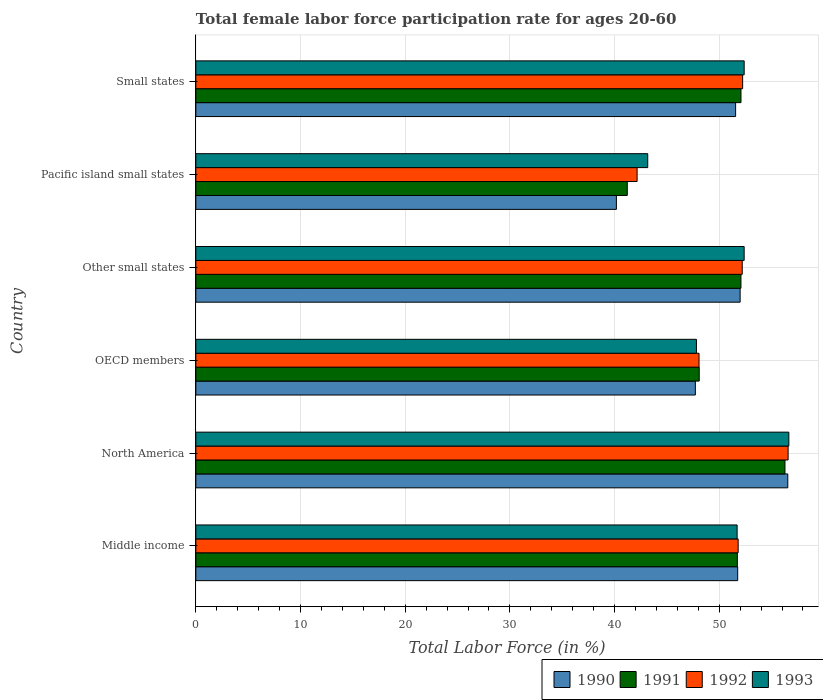How many groups of bars are there?
Offer a very short reply. 6. Are the number of bars per tick equal to the number of legend labels?
Keep it short and to the point. Yes. Are the number of bars on each tick of the Y-axis equal?
Ensure brevity in your answer.  Yes. How many bars are there on the 6th tick from the bottom?
Provide a short and direct response. 4. In how many cases, is the number of bars for a given country not equal to the number of legend labels?
Offer a very short reply. 0. What is the female labor force participation rate in 1993 in Middle income?
Give a very brief answer. 51.71. Across all countries, what is the maximum female labor force participation rate in 1991?
Keep it short and to the point. 56.28. Across all countries, what is the minimum female labor force participation rate in 1993?
Offer a terse response. 43.17. In which country was the female labor force participation rate in 1992 minimum?
Offer a terse response. Pacific island small states. What is the total female labor force participation rate in 1993 in the graph?
Offer a terse response. 304.12. What is the difference between the female labor force participation rate in 1991 in North America and that in Pacific island small states?
Offer a terse response. 15.07. What is the difference between the female labor force participation rate in 1991 in Pacific island small states and the female labor force participation rate in 1993 in Small states?
Ensure brevity in your answer.  -11.17. What is the average female labor force participation rate in 1992 per country?
Offer a terse response. 50.51. What is the difference between the female labor force participation rate in 1990 and female labor force participation rate in 1992 in Other small states?
Give a very brief answer. -0.2. What is the ratio of the female labor force participation rate in 1991 in OECD members to that in Small states?
Your response must be concise. 0.92. Is the female labor force participation rate in 1991 in OECD members less than that in Pacific island small states?
Your answer should be compact. No. What is the difference between the highest and the second highest female labor force participation rate in 1990?
Offer a very short reply. 4.55. What is the difference between the highest and the lowest female labor force participation rate in 1993?
Offer a terse response. 13.48. Is the sum of the female labor force participation rate in 1993 in Middle income and Small states greater than the maximum female labor force participation rate in 1991 across all countries?
Give a very brief answer. Yes. What does the 1st bar from the top in Small states represents?
Offer a very short reply. 1993. What does the 2nd bar from the bottom in North America represents?
Your answer should be very brief. 1991. Is it the case that in every country, the sum of the female labor force participation rate in 1990 and female labor force participation rate in 1992 is greater than the female labor force participation rate in 1993?
Offer a very short reply. Yes. How many bars are there?
Your answer should be compact. 24. Are all the bars in the graph horizontal?
Provide a succinct answer. Yes. How many countries are there in the graph?
Give a very brief answer. 6. What is the difference between two consecutive major ticks on the X-axis?
Offer a terse response. 10. Are the values on the major ticks of X-axis written in scientific E-notation?
Offer a very short reply. No. Does the graph contain grids?
Keep it short and to the point. Yes. Where does the legend appear in the graph?
Offer a terse response. Bottom right. How many legend labels are there?
Keep it short and to the point. 4. How are the legend labels stacked?
Provide a succinct answer. Horizontal. What is the title of the graph?
Your answer should be compact. Total female labor force participation rate for ages 20-60. Does "2007" appear as one of the legend labels in the graph?
Your answer should be very brief. No. What is the label or title of the X-axis?
Give a very brief answer. Total Labor Force (in %). What is the Total Labor Force (in %) in 1990 in Middle income?
Keep it short and to the point. 51.76. What is the Total Labor Force (in %) of 1991 in Middle income?
Your answer should be very brief. 51.73. What is the Total Labor Force (in %) of 1992 in Middle income?
Your answer should be compact. 51.81. What is the Total Labor Force (in %) in 1993 in Middle income?
Provide a succinct answer. 51.71. What is the Total Labor Force (in %) of 1990 in North America?
Keep it short and to the point. 56.55. What is the Total Labor Force (in %) in 1991 in North America?
Provide a succinct answer. 56.28. What is the Total Labor Force (in %) in 1992 in North America?
Your answer should be compact. 56.58. What is the Total Labor Force (in %) in 1993 in North America?
Provide a succinct answer. 56.65. What is the Total Labor Force (in %) in 1990 in OECD members?
Ensure brevity in your answer.  47.72. What is the Total Labor Force (in %) of 1991 in OECD members?
Your response must be concise. 48.09. What is the Total Labor Force (in %) in 1992 in OECD members?
Ensure brevity in your answer.  48.07. What is the Total Labor Force (in %) of 1993 in OECD members?
Make the answer very short. 47.82. What is the Total Labor Force (in %) in 1990 in Other small states?
Your answer should be very brief. 52. What is the Total Labor Force (in %) of 1991 in Other small states?
Ensure brevity in your answer.  52.08. What is the Total Labor Force (in %) in 1992 in Other small states?
Ensure brevity in your answer.  52.2. What is the Total Labor Force (in %) in 1993 in Other small states?
Offer a very short reply. 52.38. What is the Total Labor Force (in %) of 1990 in Pacific island small states?
Offer a terse response. 40.18. What is the Total Labor Force (in %) of 1991 in Pacific island small states?
Give a very brief answer. 41.21. What is the Total Labor Force (in %) in 1992 in Pacific island small states?
Make the answer very short. 42.15. What is the Total Labor Force (in %) in 1993 in Pacific island small states?
Offer a terse response. 43.17. What is the Total Labor Force (in %) of 1990 in Small states?
Offer a terse response. 51.57. What is the Total Labor Force (in %) of 1991 in Small states?
Ensure brevity in your answer.  52.08. What is the Total Labor Force (in %) of 1992 in Small states?
Your answer should be compact. 52.24. What is the Total Labor Force (in %) in 1993 in Small states?
Keep it short and to the point. 52.38. Across all countries, what is the maximum Total Labor Force (in %) of 1990?
Provide a short and direct response. 56.55. Across all countries, what is the maximum Total Labor Force (in %) in 1991?
Make the answer very short. 56.28. Across all countries, what is the maximum Total Labor Force (in %) of 1992?
Your answer should be compact. 56.58. Across all countries, what is the maximum Total Labor Force (in %) in 1993?
Offer a terse response. 56.65. Across all countries, what is the minimum Total Labor Force (in %) in 1990?
Keep it short and to the point. 40.18. Across all countries, what is the minimum Total Labor Force (in %) in 1991?
Your answer should be very brief. 41.21. Across all countries, what is the minimum Total Labor Force (in %) in 1992?
Make the answer very short. 42.15. Across all countries, what is the minimum Total Labor Force (in %) of 1993?
Give a very brief answer. 43.17. What is the total Total Labor Force (in %) in 1990 in the graph?
Offer a terse response. 299.77. What is the total Total Labor Force (in %) in 1991 in the graph?
Your answer should be compact. 301.47. What is the total Total Labor Force (in %) of 1992 in the graph?
Offer a terse response. 303.05. What is the total Total Labor Force (in %) of 1993 in the graph?
Offer a terse response. 304.12. What is the difference between the Total Labor Force (in %) of 1990 in Middle income and that in North America?
Your answer should be compact. -4.79. What is the difference between the Total Labor Force (in %) in 1991 in Middle income and that in North America?
Provide a succinct answer. -4.55. What is the difference between the Total Labor Force (in %) in 1992 in Middle income and that in North America?
Keep it short and to the point. -4.77. What is the difference between the Total Labor Force (in %) of 1993 in Middle income and that in North America?
Provide a short and direct response. -4.94. What is the difference between the Total Labor Force (in %) in 1990 in Middle income and that in OECD members?
Your answer should be very brief. 4.04. What is the difference between the Total Labor Force (in %) of 1991 in Middle income and that in OECD members?
Keep it short and to the point. 3.64. What is the difference between the Total Labor Force (in %) of 1992 in Middle income and that in OECD members?
Your answer should be compact. 3.74. What is the difference between the Total Labor Force (in %) in 1993 in Middle income and that in OECD members?
Your response must be concise. 3.89. What is the difference between the Total Labor Force (in %) in 1990 in Middle income and that in Other small states?
Your answer should be very brief. -0.23. What is the difference between the Total Labor Force (in %) in 1991 in Middle income and that in Other small states?
Ensure brevity in your answer.  -0.34. What is the difference between the Total Labor Force (in %) in 1992 in Middle income and that in Other small states?
Ensure brevity in your answer.  -0.39. What is the difference between the Total Labor Force (in %) of 1993 in Middle income and that in Other small states?
Offer a terse response. -0.67. What is the difference between the Total Labor Force (in %) of 1990 in Middle income and that in Pacific island small states?
Keep it short and to the point. 11.59. What is the difference between the Total Labor Force (in %) in 1991 in Middle income and that in Pacific island small states?
Your answer should be very brief. 10.52. What is the difference between the Total Labor Force (in %) in 1992 in Middle income and that in Pacific island small states?
Give a very brief answer. 9.65. What is the difference between the Total Labor Force (in %) of 1993 in Middle income and that in Pacific island small states?
Ensure brevity in your answer.  8.54. What is the difference between the Total Labor Force (in %) of 1990 in Middle income and that in Small states?
Ensure brevity in your answer.  0.2. What is the difference between the Total Labor Force (in %) in 1991 in Middle income and that in Small states?
Give a very brief answer. -0.35. What is the difference between the Total Labor Force (in %) of 1992 in Middle income and that in Small states?
Keep it short and to the point. -0.43. What is the difference between the Total Labor Force (in %) in 1993 in Middle income and that in Small states?
Offer a terse response. -0.67. What is the difference between the Total Labor Force (in %) in 1990 in North America and that in OECD members?
Offer a terse response. 8.83. What is the difference between the Total Labor Force (in %) in 1991 in North America and that in OECD members?
Provide a short and direct response. 8.19. What is the difference between the Total Labor Force (in %) of 1992 in North America and that in OECD members?
Ensure brevity in your answer.  8.51. What is the difference between the Total Labor Force (in %) of 1993 in North America and that in OECD members?
Provide a short and direct response. 8.83. What is the difference between the Total Labor Force (in %) in 1990 in North America and that in Other small states?
Offer a terse response. 4.55. What is the difference between the Total Labor Force (in %) of 1991 in North America and that in Other small states?
Offer a terse response. 4.2. What is the difference between the Total Labor Force (in %) of 1992 in North America and that in Other small states?
Your response must be concise. 4.38. What is the difference between the Total Labor Force (in %) of 1993 in North America and that in Other small states?
Provide a short and direct response. 4.27. What is the difference between the Total Labor Force (in %) of 1990 in North America and that in Pacific island small states?
Provide a succinct answer. 16.37. What is the difference between the Total Labor Force (in %) of 1991 in North America and that in Pacific island small states?
Offer a very short reply. 15.07. What is the difference between the Total Labor Force (in %) of 1992 in North America and that in Pacific island small states?
Your answer should be very brief. 14.43. What is the difference between the Total Labor Force (in %) of 1993 in North America and that in Pacific island small states?
Offer a very short reply. 13.48. What is the difference between the Total Labor Force (in %) in 1990 in North America and that in Small states?
Your answer should be very brief. 4.98. What is the difference between the Total Labor Force (in %) in 1991 in North America and that in Small states?
Provide a succinct answer. 4.2. What is the difference between the Total Labor Force (in %) in 1992 in North America and that in Small states?
Offer a very short reply. 4.34. What is the difference between the Total Labor Force (in %) in 1993 in North America and that in Small states?
Offer a terse response. 4.27. What is the difference between the Total Labor Force (in %) in 1990 in OECD members and that in Other small states?
Your answer should be compact. -4.28. What is the difference between the Total Labor Force (in %) of 1991 in OECD members and that in Other small states?
Give a very brief answer. -3.99. What is the difference between the Total Labor Force (in %) in 1992 in OECD members and that in Other small states?
Offer a very short reply. -4.13. What is the difference between the Total Labor Force (in %) in 1993 in OECD members and that in Other small states?
Make the answer very short. -4.56. What is the difference between the Total Labor Force (in %) in 1990 in OECD members and that in Pacific island small states?
Give a very brief answer. 7.54. What is the difference between the Total Labor Force (in %) in 1991 in OECD members and that in Pacific island small states?
Provide a succinct answer. 6.87. What is the difference between the Total Labor Force (in %) of 1992 in OECD members and that in Pacific island small states?
Your answer should be compact. 5.92. What is the difference between the Total Labor Force (in %) of 1993 in OECD members and that in Pacific island small states?
Provide a succinct answer. 4.65. What is the difference between the Total Labor Force (in %) of 1990 in OECD members and that in Small states?
Your response must be concise. -3.85. What is the difference between the Total Labor Force (in %) of 1991 in OECD members and that in Small states?
Provide a short and direct response. -3.99. What is the difference between the Total Labor Force (in %) in 1992 in OECD members and that in Small states?
Provide a succinct answer. -4.17. What is the difference between the Total Labor Force (in %) of 1993 in OECD members and that in Small states?
Ensure brevity in your answer.  -4.56. What is the difference between the Total Labor Force (in %) of 1990 in Other small states and that in Pacific island small states?
Provide a short and direct response. 11.82. What is the difference between the Total Labor Force (in %) of 1991 in Other small states and that in Pacific island small states?
Provide a short and direct response. 10.86. What is the difference between the Total Labor Force (in %) of 1992 in Other small states and that in Pacific island small states?
Your answer should be very brief. 10.04. What is the difference between the Total Labor Force (in %) of 1993 in Other small states and that in Pacific island small states?
Offer a terse response. 9.21. What is the difference between the Total Labor Force (in %) of 1990 in Other small states and that in Small states?
Your response must be concise. 0.43. What is the difference between the Total Labor Force (in %) of 1991 in Other small states and that in Small states?
Provide a short and direct response. -0. What is the difference between the Total Labor Force (in %) of 1992 in Other small states and that in Small states?
Provide a succinct answer. -0.04. What is the difference between the Total Labor Force (in %) of 1993 in Other small states and that in Small states?
Give a very brief answer. -0. What is the difference between the Total Labor Force (in %) of 1990 in Pacific island small states and that in Small states?
Your answer should be compact. -11.39. What is the difference between the Total Labor Force (in %) of 1991 in Pacific island small states and that in Small states?
Offer a terse response. -10.86. What is the difference between the Total Labor Force (in %) in 1992 in Pacific island small states and that in Small states?
Give a very brief answer. -10.08. What is the difference between the Total Labor Force (in %) in 1993 in Pacific island small states and that in Small states?
Keep it short and to the point. -9.21. What is the difference between the Total Labor Force (in %) of 1990 in Middle income and the Total Labor Force (in %) of 1991 in North America?
Offer a very short reply. -4.52. What is the difference between the Total Labor Force (in %) in 1990 in Middle income and the Total Labor Force (in %) in 1992 in North America?
Offer a very short reply. -4.82. What is the difference between the Total Labor Force (in %) of 1990 in Middle income and the Total Labor Force (in %) of 1993 in North America?
Provide a short and direct response. -4.89. What is the difference between the Total Labor Force (in %) in 1991 in Middle income and the Total Labor Force (in %) in 1992 in North America?
Your answer should be very brief. -4.85. What is the difference between the Total Labor Force (in %) of 1991 in Middle income and the Total Labor Force (in %) of 1993 in North America?
Make the answer very short. -4.92. What is the difference between the Total Labor Force (in %) in 1992 in Middle income and the Total Labor Force (in %) in 1993 in North America?
Provide a short and direct response. -4.84. What is the difference between the Total Labor Force (in %) of 1990 in Middle income and the Total Labor Force (in %) of 1991 in OECD members?
Offer a very short reply. 3.68. What is the difference between the Total Labor Force (in %) of 1990 in Middle income and the Total Labor Force (in %) of 1992 in OECD members?
Offer a very short reply. 3.69. What is the difference between the Total Labor Force (in %) of 1990 in Middle income and the Total Labor Force (in %) of 1993 in OECD members?
Offer a very short reply. 3.94. What is the difference between the Total Labor Force (in %) of 1991 in Middle income and the Total Labor Force (in %) of 1992 in OECD members?
Your response must be concise. 3.66. What is the difference between the Total Labor Force (in %) in 1991 in Middle income and the Total Labor Force (in %) in 1993 in OECD members?
Your answer should be very brief. 3.91. What is the difference between the Total Labor Force (in %) in 1992 in Middle income and the Total Labor Force (in %) in 1993 in OECD members?
Offer a very short reply. 3.99. What is the difference between the Total Labor Force (in %) in 1990 in Middle income and the Total Labor Force (in %) in 1991 in Other small states?
Make the answer very short. -0.31. What is the difference between the Total Labor Force (in %) of 1990 in Middle income and the Total Labor Force (in %) of 1992 in Other small states?
Your response must be concise. -0.43. What is the difference between the Total Labor Force (in %) in 1990 in Middle income and the Total Labor Force (in %) in 1993 in Other small states?
Provide a short and direct response. -0.62. What is the difference between the Total Labor Force (in %) in 1991 in Middle income and the Total Labor Force (in %) in 1992 in Other small states?
Your response must be concise. -0.47. What is the difference between the Total Labor Force (in %) of 1991 in Middle income and the Total Labor Force (in %) of 1993 in Other small states?
Offer a very short reply. -0.65. What is the difference between the Total Labor Force (in %) in 1992 in Middle income and the Total Labor Force (in %) in 1993 in Other small states?
Keep it short and to the point. -0.57. What is the difference between the Total Labor Force (in %) of 1990 in Middle income and the Total Labor Force (in %) of 1991 in Pacific island small states?
Offer a very short reply. 10.55. What is the difference between the Total Labor Force (in %) of 1990 in Middle income and the Total Labor Force (in %) of 1992 in Pacific island small states?
Ensure brevity in your answer.  9.61. What is the difference between the Total Labor Force (in %) in 1990 in Middle income and the Total Labor Force (in %) in 1993 in Pacific island small states?
Make the answer very short. 8.59. What is the difference between the Total Labor Force (in %) of 1991 in Middle income and the Total Labor Force (in %) of 1992 in Pacific island small states?
Offer a terse response. 9.58. What is the difference between the Total Labor Force (in %) of 1991 in Middle income and the Total Labor Force (in %) of 1993 in Pacific island small states?
Your answer should be very brief. 8.56. What is the difference between the Total Labor Force (in %) of 1992 in Middle income and the Total Labor Force (in %) of 1993 in Pacific island small states?
Provide a succinct answer. 8.64. What is the difference between the Total Labor Force (in %) of 1990 in Middle income and the Total Labor Force (in %) of 1991 in Small states?
Give a very brief answer. -0.32. What is the difference between the Total Labor Force (in %) in 1990 in Middle income and the Total Labor Force (in %) in 1992 in Small states?
Provide a short and direct response. -0.47. What is the difference between the Total Labor Force (in %) in 1990 in Middle income and the Total Labor Force (in %) in 1993 in Small states?
Offer a terse response. -0.62. What is the difference between the Total Labor Force (in %) in 1991 in Middle income and the Total Labor Force (in %) in 1992 in Small states?
Offer a very short reply. -0.5. What is the difference between the Total Labor Force (in %) in 1991 in Middle income and the Total Labor Force (in %) in 1993 in Small states?
Your answer should be compact. -0.65. What is the difference between the Total Labor Force (in %) of 1992 in Middle income and the Total Labor Force (in %) of 1993 in Small states?
Your response must be concise. -0.57. What is the difference between the Total Labor Force (in %) in 1990 in North America and the Total Labor Force (in %) in 1991 in OECD members?
Keep it short and to the point. 8.46. What is the difference between the Total Labor Force (in %) in 1990 in North America and the Total Labor Force (in %) in 1992 in OECD members?
Ensure brevity in your answer.  8.48. What is the difference between the Total Labor Force (in %) in 1990 in North America and the Total Labor Force (in %) in 1993 in OECD members?
Give a very brief answer. 8.73. What is the difference between the Total Labor Force (in %) in 1991 in North America and the Total Labor Force (in %) in 1992 in OECD members?
Provide a succinct answer. 8.21. What is the difference between the Total Labor Force (in %) in 1991 in North America and the Total Labor Force (in %) in 1993 in OECD members?
Offer a terse response. 8.46. What is the difference between the Total Labor Force (in %) of 1992 in North America and the Total Labor Force (in %) of 1993 in OECD members?
Your answer should be compact. 8.76. What is the difference between the Total Labor Force (in %) of 1990 in North America and the Total Labor Force (in %) of 1991 in Other small states?
Give a very brief answer. 4.47. What is the difference between the Total Labor Force (in %) in 1990 in North America and the Total Labor Force (in %) in 1992 in Other small states?
Provide a short and direct response. 4.35. What is the difference between the Total Labor Force (in %) of 1990 in North America and the Total Labor Force (in %) of 1993 in Other small states?
Provide a succinct answer. 4.17. What is the difference between the Total Labor Force (in %) of 1991 in North America and the Total Labor Force (in %) of 1992 in Other small states?
Offer a very short reply. 4.08. What is the difference between the Total Labor Force (in %) of 1991 in North America and the Total Labor Force (in %) of 1993 in Other small states?
Make the answer very short. 3.9. What is the difference between the Total Labor Force (in %) in 1992 in North America and the Total Labor Force (in %) in 1993 in Other small states?
Give a very brief answer. 4.2. What is the difference between the Total Labor Force (in %) of 1990 in North America and the Total Labor Force (in %) of 1991 in Pacific island small states?
Offer a terse response. 15.34. What is the difference between the Total Labor Force (in %) in 1990 in North America and the Total Labor Force (in %) in 1992 in Pacific island small states?
Offer a terse response. 14.4. What is the difference between the Total Labor Force (in %) in 1990 in North America and the Total Labor Force (in %) in 1993 in Pacific island small states?
Offer a terse response. 13.38. What is the difference between the Total Labor Force (in %) in 1991 in North America and the Total Labor Force (in %) in 1992 in Pacific island small states?
Ensure brevity in your answer.  14.13. What is the difference between the Total Labor Force (in %) in 1991 in North America and the Total Labor Force (in %) in 1993 in Pacific island small states?
Your answer should be compact. 13.11. What is the difference between the Total Labor Force (in %) in 1992 in North America and the Total Labor Force (in %) in 1993 in Pacific island small states?
Offer a very short reply. 13.41. What is the difference between the Total Labor Force (in %) of 1990 in North America and the Total Labor Force (in %) of 1991 in Small states?
Your response must be concise. 4.47. What is the difference between the Total Labor Force (in %) of 1990 in North America and the Total Labor Force (in %) of 1992 in Small states?
Offer a terse response. 4.31. What is the difference between the Total Labor Force (in %) of 1990 in North America and the Total Labor Force (in %) of 1993 in Small states?
Keep it short and to the point. 4.17. What is the difference between the Total Labor Force (in %) in 1991 in North America and the Total Labor Force (in %) in 1992 in Small states?
Provide a short and direct response. 4.04. What is the difference between the Total Labor Force (in %) of 1991 in North America and the Total Labor Force (in %) of 1993 in Small states?
Give a very brief answer. 3.9. What is the difference between the Total Labor Force (in %) of 1992 in North America and the Total Labor Force (in %) of 1993 in Small states?
Ensure brevity in your answer.  4.2. What is the difference between the Total Labor Force (in %) of 1990 in OECD members and the Total Labor Force (in %) of 1991 in Other small states?
Your answer should be very brief. -4.36. What is the difference between the Total Labor Force (in %) of 1990 in OECD members and the Total Labor Force (in %) of 1992 in Other small states?
Your answer should be very brief. -4.48. What is the difference between the Total Labor Force (in %) in 1990 in OECD members and the Total Labor Force (in %) in 1993 in Other small states?
Your response must be concise. -4.66. What is the difference between the Total Labor Force (in %) of 1991 in OECD members and the Total Labor Force (in %) of 1992 in Other small states?
Offer a terse response. -4.11. What is the difference between the Total Labor Force (in %) of 1991 in OECD members and the Total Labor Force (in %) of 1993 in Other small states?
Ensure brevity in your answer.  -4.29. What is the difference between the Total Labor Force (in %) of 1992 in OECD members and the Total Labor Force (in %) of 1993 in Other small states?
Your answer should be very brief. -4.31. What is the difference between the Total Labor Force (in %) of 1990 in OECD members and the Total Labor Force (in %) of 1991 in Pacific island small states?
Provide a short and direct response. 6.5. What is the difference between the Total Labor Force (in %) in 1990 in OECD members and the Total Labor Force (in %) in 1992 in Pacific island small states?
Your answer should be compact. 5.57. What is the difference between the Total Labor Force (in %) of 1990 in OECD members and the Total Labor Force (in %) of 1993 in Pacific island small states?
Your answer should be very brief. 4.55. What is the difference between the Total Labor Force (in %) of 1991 in OECD members and the Total Labor Force (in %) of 1992 in Pacific island small states?
Ensure brevity in your answer.  5.93. What is the difference between the Total Labor Force (in %) in 1991 in OECD members and the Total Labor Force (in %) in 1993 in Pacific island small states?
Keep it short and to the point. 4.92. What is the difference between the Total Labor Force (in %) of 1992 in OECD members and the Total Labor Force (in %) of 1993 in Pacific island small states?
Ensure brevity in your answer.  4.9. What is the difference between the Total Labor Force (in %) of 1990 in OECD members and the Total Labor Force (in %) of 1991 in Small states?
Offer a terse response. -4.36. What is the difference between the Total Labor Force (in %) in 1990 in OECD members and the Total Labor Force (in %) in 1992 in Small states?
Provide a short and direct response. -4.52. What is the difference between the Total Labor Force (in %) in 1990 in OECD members and the Total Labor Force (in %) in 1993 in Small states?
Provide a succinct answer. -4.66. What is the difference between the Total Labor Force (in %) of 1991 in OECD members and the Total Labor Force (in %) of 1992 in Small states?
Your answer should be compact. -4.15. What is the difference between the Total Labor Force (in %) of 1991 in OECD members and the Total Labor Force (in %) of 1993 in Small states?
Keep it short and to the point. -4.29. What is the difference between the Total Labor Force (in %) of 1992 in OECD members and the Total Labor Force (in %) of 1993 in Small states?
Make the answer very short. -4.31. What is the difference between the Total Labor Force (in %) of 1990 in Other small states and the Total Labor Force (in %) of 1991 in Pacific island small states?
Provide a succinct answer. 10.78. What is the difference between the Total Labor Force (in %) of 1990 in Other small states and the Total Labor Force (in %) of 1992 in Pacific island small states?
Ensure brevity in your answer.  9.84. What is the difference between the Total Labor Force (in %) of 1990 in Other small states and the Total Labor Force (in %) of 1993 in Pacific island small states?
Ensure brevity in your answer.  8.83. What is the difference between the Total Labor Force (in %) of 1991 in Other small states and the Total Labor Force (in %) of 1992 in Pacific island small states?
Provide a succinct answer. 9.92. What is the difference between the Total Labor Force (in %) of 1991 in Other small states and the Total Labor Force (in %) of 1993 in Pacific island small states?
Ensure brevity in your answer.  8.91. What is the difference between the Total Labor Force (in %) in 1992 in Other small states and the Total Labor Force (in %) in 1993 in Pacific island small states?
Give a very brief answer. 9.03. What is the difference between the Total Labor Force (in %) of 1990 in Other small states and the Total Labor Force (in %) of 1991 in Small states?
Offer a very short reply. -0.08. What is the difference between the Total Labor Force (in %) of 1990 in Other small states and the Total Labor Force (in %) of 1992 in Small states?
Ensure brevity in your answer.  -0.24. What is the difference between the Total Labor Force (in %) of 1990 in Other small states and the Total Labor Force (in %) of 1993 in Small states?
Offer a very short reply. -0.39. What is the difference between the Total Labor Force (in %) in 1991 in Other small states and the Total Labor Force (in %) in 1992 in Small states?
Your answer should be compact. -0.16. What is the difference between the Total Labor Force (in %) in 1991 in Other small states and the Total Labor Force (in %) in 1993 in Small states?
Your response must be concise. -0.31. What is the difference between the Total Labor Force (in %) of 1992 in Other small states and the Total Labor Force (in %) of 1993 in Small states?
Your answer should be very brief. -0.19. What is the difference between the Total Labor Force (in %) in 1990 in Pacific island small states and the Total Labor Force (in %) in 1991 in Small states?
Ensure brevity in your answer.  -11.9. What is the difference between the Total Labor Force (in %) in 1990 in Pacific island small states and the Total Labor Force (in %) in 1992 in Small states?
Give a very brief answer. -12.06. What is the difference between the Total Labor Force (in %) of 1990 in Pacific island small states and the Total Labor Force (in %) of 1993 in Small states?
Offer a very short reply. -12.21. What is the difference between the Total Labor Force (in %) of 1991 in Pacific island small states and the Total Labor Force (in %) of 1992 in Small states?
Your answer should be very brief. -11.02. What is the difference between the Total Labor Force (in %) of 1991 in Pacific island small states and the Total Labor Force (in %) of 1993 in Small states?
Make the answer very short. -11.17. What is the difference between the Total Labor Force (in %) of 1992 in Pacific island small states and the Total Labor Force (in %) of 1993 in Small states?
Provide a short and direct response. -10.23. What is the average Total Labor Force (in %) in 1990 per country?
Provide a short and direct response. 49.96. What is the average Total Labor Force (in %) in 1991 per country?
Your answer should be compact. 50.24. What is the average Total Labor Force (in %) of 1992 per country?
Make the answer very short. 50.51. What is the average Total Labor Force (in %) of 1993 per country?
Offer a very short reply. 50.69. What is the difference between the Total Labor Force (in %) in 1990 and Total Labor Force (in %) in 1991 in Middle income?
Provide a short and direct response. 0.03. What is the difference between the Total Labor Force (in %) of 1990 and Total Labor Force (in %) of 1992 in Middle income?
Keep it short and to the point. -0.05. What is the difference between the Total Labor Force (in %) of 1990 and Total Labor Force (in %) of 1993 in Middle income?
Offer a terse response. 0.05. What is the difference between the Total Labor Force (in %) of 1991 and Total Labor Force (in %) of 1992 in Middle income?
Keep it short and to the point. -0.08. What is the difference between the Total Labor Force (in %) of 1991 and Total Labor Force (in %) of 1993 in Middle income?
Your response must be concise. 0.02. What is the difference between the Total Labor Force (in %) of 1992 and Total Labor Force (in %) of 1993 in Middle income?
Offer a terse response. 0.1. What is the difference between the Total Labor Force (in %) of 1990 and Total Labor Force (in %) of 1991 in North America?
Keep it short and to the point. 0.27. What is the difference between the Total Labor Force (in %) in 1990 and Total Labor Force (in %) in 1992 in North America?
Offer a very short reply. -0.03. What is the difference between the Total Labor Force (in %) in 1990 and Total Labor Force (in %) in 1993 in North America?
Offer a very short reply. -0.1. What is the difference between the Total Labor Force (in %) of 1991 and Total Labor Force (in %) of 1992 in North America?
Give a very brief answer. -0.3. What is the difference between the Total Labor Force (in %) in 1991 and Total Labor Force (in %) in 1993 in North America?
Provide a short and direct response. -0.37. What is the difference between the Total Labor Force (in %) of 1992 and Total Labor Force (in %) of 1993 in North America?
Offer a very short reply. -0.07. What is the difference between the Total Labor Force (in %) of 1990 and Total Labor Force (in %) of 1991 in OECD members?
Keep it short and to the point. -0.37. What is the difference between the Total Labor Force (in %) in 1990 and Total Labor Force (in %) in 1992 in OECD members?
Your answer should be compact. -0.35. What is the difference between the Total Labor Force (in %) in 1990 and Total Labor Force (in %) in 1993 in OECD members?
Your answer should be compact. -0.1. What is the difference between the Total Labor Force (in %) in 1991 and Total Labor Force (in %) in 1992 in OECD members?
Provide a succinct answer. 0.02. What is the difference between the Total Labor Force (in %) in 1991 and Total Labor Force (in %) in 1993 in OECD members?
Offer a terse response. 0.27. What is the difference between the Total Labor Force (in %) of 1992 and Total Labor Force (in %) of 1993 in OECD members?
Provide a short and direct response. 0.25. What is the difference between the Total Labor Force (in %) in 1990 and Total Labor Force (in %) in 1991 in Other small states?
Provide a succinct answer. -0.08. What is the difference between the Total Labor Force (in %) in 1990 and Total Labor Force (in %) in 1992 in Other small states?
Your response must be concise. -0.2. What is the difference between the Total Labor Force (in %) in 1990 and Total Labor Force (in %) in 1993 in Other small states?
Make the answer very short. -0.39. What is the difference between the Total Labor Force (in %) of 1991 and Total Labor Force (in %) of 1992 in Other small states?
Your answer should be very brief. -0.12. What is the difference between the Total Labor Force (in %) in 1991 and Total Labor Force (in %) in 1993 in Other small states?
Keep it short and to the point. -0.31. What is the difference between the Total Labor Force (in %) in 1992 and Total Labor Force (in %) in 1993 in Other small states?
Provide a succinct answer. -0.18. What is the difference between the Total Labor Force (in %) in 1990 and Total Labor Force (in %) in 1991 in Pacific island small states?
Give a very brief answer. -1.04. What is the difference between the Total Labor Force (in %) in 1990 and Total Labor Force (in %) in 1992 in Pacific island small states?
Offer a terse response. -1.98. What is the difference between the Total Labor Force (in %) of 1990 and Total Labor Force (in %) of 1993 in Pacific island small states?
Keep it short and to the point. -2.99. What is the difference between the Total Labor Force (in %) of 1991 and Total Labor Force (in %) of 1992 in Pacific island small states?
Offer a very short reply. -0.94. What is the difference between the Total Labor Force (in %) of 1991 and Total Labor Force (in %) of 1993 in Pacific island small states?
Make the answer very short. -1.96. What is the difference between the Total Labor Force (in %) of 1992 and Total Labor Force (in %) of 1993 in Pacific island small states?
Offer a very short reply. -1.02. What is the difference between the Total Labor Force (in %) of 1990 and Total Labor Force (in %) of 1991 in Small states?
Your response must be concise. -0.51. What is the difference between the Total Labor Force (in %) in 1990 and Total Labor Force (in %) in 1992 in Small states?
Offer a terse response. -0.67. What is the difference between the Total Labor Force (in %) in 1990 and Total Labor Force (in %) in 1993 in Small states?
Your answer should be very brief. -0.82. What is the difference between the Total Labor Force (in %) of 1991 and Total Labor Force (in %) of 1992 in Small states?
Provide a short and direct response. -0.16. What is the difference between the Total Labor Force (in %) of 1991 and Total Labor Force (in %) of 1993 in Small states?
Your answer should be compact. -0.3. What is the difference between the Total Labor Force (in %) of 1992 and Total Labor Force (in %) of 1993 in Small states?
Keep it short and to the point. -0.15. What is the ratio of the Total Labor Force (in %) of 1990 in Middle income to that in North America?
Offer a terse response. 0.92. What is the ratio of the Total Labor Force (in %) in 1991 in Middle income to that in North America?
Provide a short and direct response. 0.92. What is the ratio of the Total Labor Force (in %) in 1992 in Middle income to that in North America?
Offer a very short reply. 0.92. What is the ratio of the Total Labor Force (in %) in 1993 in Middle income to that in North America?
Make the answer very short. 0.91. What is the ratio of the Total Labor Force (in %) of 1990 in Middle income to that in OECD members?
Offer a very short reply. 1.08. What is the ratio of the Total Labor Force (in %) of 1991 in Middle income to that in OECD members?
Provide a short and direct response. 1.08. What is the ratio of the Total Labor Force (in %) of 1992 in Middle income to that in OECD members?
Keep it short and to the point. 1.08. What is the ratio of the Total Labor Force (in %) in 1993 in Middle income to that in OECD members?
Your answer should be very brief. 1.08. What is the ratio of the Total Labor Force (in %) in 1993 in Middle income to that in Other small states?
Ensure brevity in your answer.  0.99. What is the ratio of the Total Labor Force (in %) in 1990 in Middle income to that in Pacific island small states?
Offer a very short reply. 1.29. What is the ratio of the Total Labor Force (in %) in 1991 in Middle income to that in Pacific island small states?
Your answer should be compact. 1.26. What is the ratio of the Total Labor Force (in %) in 1992 in Middle income to that in Pacific island small states?
Ensure brevity in your answer.  1.23. What is the ratio of the Total Labor Force (in %) in 1993 in Middle income to that in Pacific island small states?
Offer a terse response. 1.2. What is the ratio of the Total Labor Force (in %) in 1990 in Middle income to that in Small states?
Offer a terse response. 1. What is the ratio of the Total Labor Force (in %) of 1991 in Middle income to that in Small states?
Provide a short and direct response. 0.99. What is the ratio of the Total Labor Force (in %) of 1992 in Middle income to that in Small states?
Provide a succinct answer. 0.99. What is the ratio of the Total Labor Force (in %) of 1993 in Middle income to that in Small states?
Your response must be concise. 0.99. What is the ratio of the Total Labor Force (in %) in 1990 in North America to that in OECD members?
Ensure brevity in your answer.  1.19. What is the ratio of the Total Labor Force (in %) of 1991 in North America to that in OECD members?
Your answer should be compact. 1.17. What is the ratio of the Total Labor Force (in %) in 1992 in North America to that in OECD members?
Give a very brief answer. 1.18. What is the ratio of the Total Labor Force (in %) in 1993 in North America to that in OECD members?
Your answer should be compact. 1.18. What is the ratio of the Total Labor Force (in %) in 1990 in North America to that in Other small states?
Your answer should be compact. 1.09. What is the ratio of the Total Labor Force (in %) in 1991 in North America to that in Other small states?
Your response must be concise. 1.08. What is the ratio of the Total Labor Force (in %) in 1992 in North America to that in Other small states?
Provide a succinct answer. 1.08. What is the ratio of the Total Labor Force (in %) of 1993 in North America to that in Other small states?
Give a very brief answer. 1.08. What is the ratio of the Total Labor Force (in %) of 1990 in North America to that in Pacific island small states?
Ensure brevity in your answer.  1.41. What is the ratio of the Total Labor Force (in %) in 1991 in North America to that in Pacific island small states?
Keep it short and to the point. 1.37. What is the ratio of the Total Labor Force (in %) in 1992 in North America to that in Pacific island small states?
Make the answer very short. 1.34. What is the ratio of the Total Labor Force (in %) in 1993 in North America to that in Pacific island small states?
Provide a short and direct response. 1.31. What is the ratio of the Total Labor Force (in %) in 1990 in North America to that in Small states?
Ensure brevity in your answer.  1.1. What is the ratio of the Total Labor Force (in %) in 1991 in North America to that in Small states?
Keep it short and to the point. 1.08. What is the ratio of the Total Labor Force (in %) in 1992 in North America to that in Small states?
Your answer should be very brief. 1.08. What is the ratio of the Total Labor Force (in %) in 1993 in North America to that in Small states?
Offer a terse response. 1.08. What is the ratio of the Total Labor Force (in %) in 1990 in OECD members to that in Other small states?
Provide a short and direct response. 0.92. What is the ratio of the Total Labor Force (in %) of 1991 in OECD members to that in Other small states?
Ensure brevity in your answer.  0.92. What is the ratio of the Total Labor Force (in %) in 1992 in OECD members to that in Other small states?
Ensure brevity in your answer.  0.92. What is the ratio of the Total Labor Force (in %) of 1990 in OECD members to that in Pacific island small states?
Your answer should be compact. 1.19. What is the ratio of the Total Labor Force (in %) in 1991 in OECD members to that in Pacific island small states?
Your answer should be very brief. 1.17. What is the ratio of the Total Labor Force (in %) in 1992 in OECD members to that in Pacific island small states?
Keep it short and to the point. 1.14. What is the ratio of the Total Labor Force (in %) in 1993 in OECD members to that in Pacific island small states?
Offer a very short reply. 1.11. What is the ratio of the Total Labor Force (in %) in 1990 in OECD members to that in Small states?
Give a very brief answer. 0.93. What is the ratio of the Total Labor Force (in %) in 1991 in OECD members to that in Small states?
Make the answer very short. 0.92. What is the ratio of the Total Labor Force (in %) of 1992 in OECD members to that in Small states?
Provide a succinct answer. 0.92. What is the ratio of the Total Labor Force (in %) of 1993 in OECD members to that in Small states?
Give a very brief answer. 0.91. What is the ratio of the Total Labor Force (in %) in 1990 in Other small states to that in Pacific island small states?
Keep it short and to the point. 1.29. What is the ratio of the Total Labor Force (in %) of 1991 in Other small states to that in Pacific island small states?
Offer a terse response. 1.26. What is the ratio of the Total Labor Force (in %) in 1992 in Other small states to that in Pacific island small states?
Your answer should be compact. 1.24. What is the ratio of the Total Labor Force (in %) in 1993 in Other small states to that in Pacific island small states?
Ensure brevity in your answer.  1.21. What is the ratio of the Total Labor Force (in %) in 1990 in Other small states to that in Small states?
Offer a very short reply. 1.01. What is the ratio of the Total Labor Force (in %) in 1991 in Other small states to that in Small states?
Ensure brevity in your answer.  1. What is the ratio of the Total Labor Force (in %) in 1992 in Other small states to that in Small states?
Provide a succinct answer. 1. What is the ratio of the Total Labor Force (in %) of 1993 in Other small states to that in Small states?
Your response must be concise. 1. What is the ratio of the Total Labor Force (in %) in 1990 in Pacific island small states to that in Small states?
Offer a very short reply. 0.78. What is the ratio of the Total Labor Force (in %) in 1991 in Pacific island small states to that in Small states?
Provide a succinct answer. 0.79. What is the ratio of the Total Labor Force (in %) of 1992 in Pacific island small states to that in Small states?
Your answer should be very brief. 0.81. What is the ratio of the Total Labor Force (in %) in 1993 in Pacific island small states to that in Small states?
Provide a succinct answer. 0.82. What is the difference between the highest and the second highest Total Labor Force (in %) of 1990?
Your answer should be compact. 4.55. What is the difference between the highest and the second highest Total Labor Force (in %) in 1991?
Give a very brief answer. 4.2. What is the difference between the highest and the second highest Total Labor Force (in %) of 1992?
Your response must be concise. 4.34. What is the difference between the highest and the second highest Total Labor Force (in %) of 1993?
Offer a very short reply. 4.27. What is the difference between the highest and the lowest Total Labor Force (in %) of 1990?
Make the answer very short. 16.37. What is the difference between the highest and the lowest Total Labor Force (in %) of 1991?
Provide a short and direct response. 15.07. What is the difference between the highest and the lowest Total Labor Force (in %) in 1992?
Your answer should be very brief. 14.43. What is the difference between the highest and the lowest Total Labor Force (in %) of 1993?
Keep it short and to the point. 13.48. 